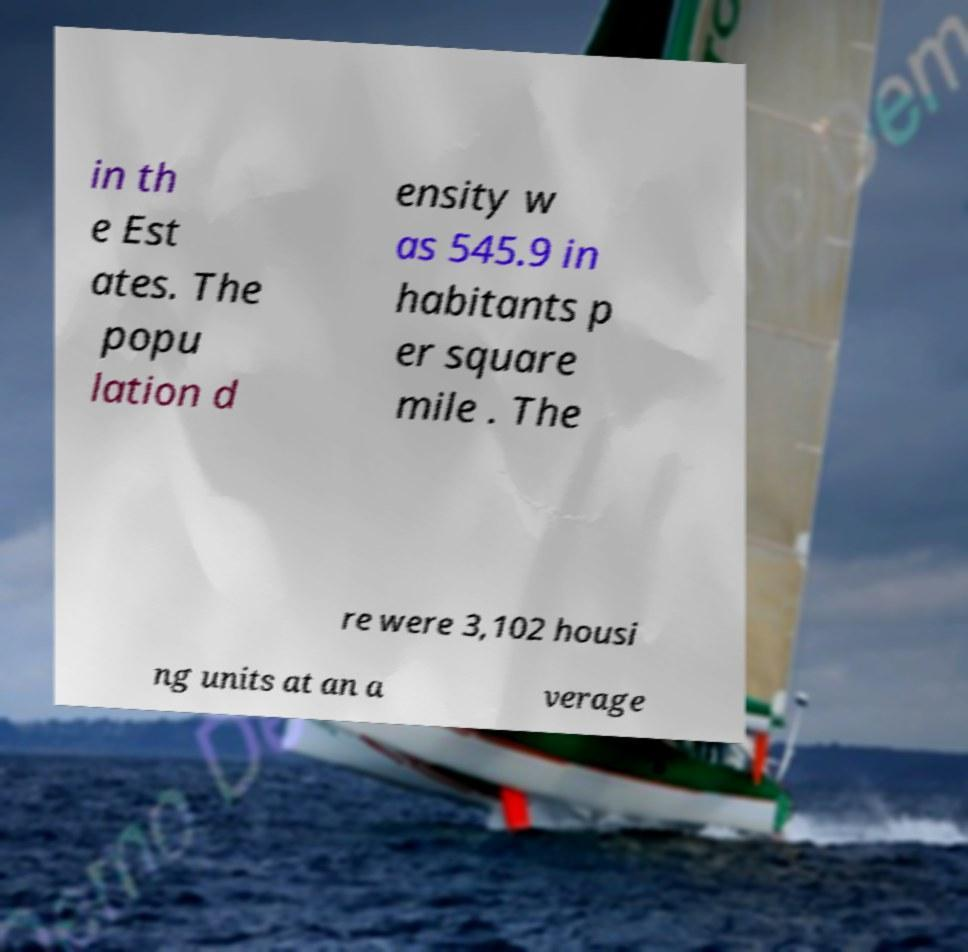Please identify and transcribe the text found in this image. in th e Est ates. The popu lation d ensity w as 545.9 in habitants p er square mile . The re were 3,102 housi ng units at an a verage 